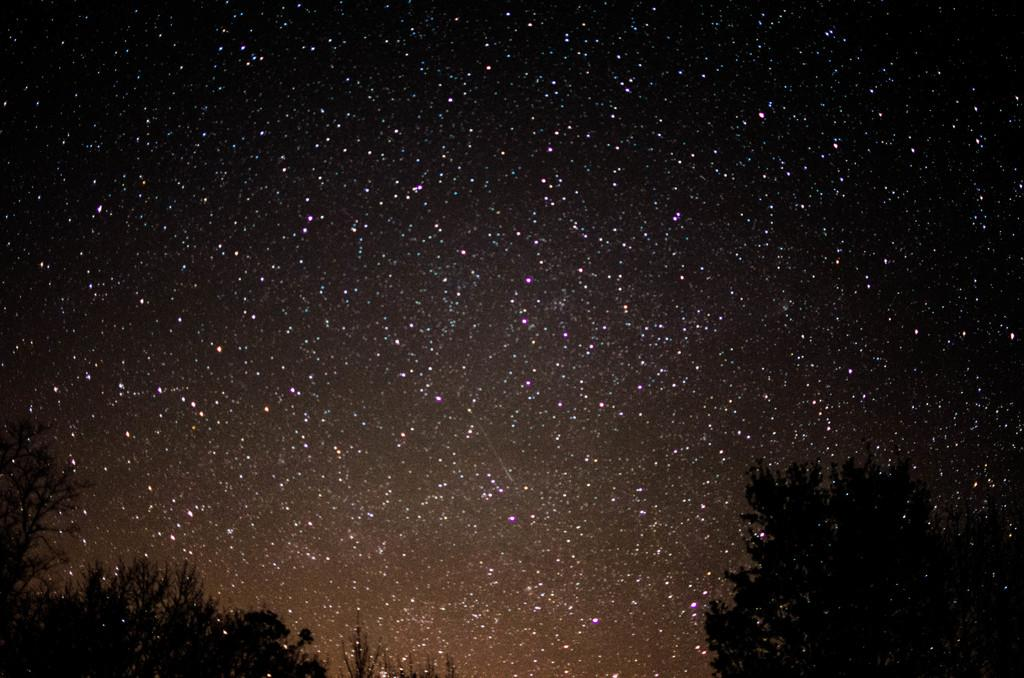What type of vegetation can be seen at the bottom of the image? There are trees in the right bottom and left bottom of the image. What can be seen in the background of the image? The sky and stars are present in the background of the image. What might be inferred about the environment in which the image was taken? The image was taken in a dark environment. What type of silk is stored in the drawer in the image? There is no drawer or silk present in the image. 